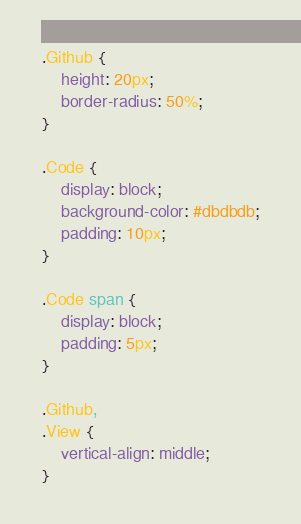<code> <loc_0><loc_0><loc_500><loc_500><_CSS_>.Github {
	height: 20px;
	border-radius: 50%;
}

.Code {
	display: block;
	background-color: #dbdbdb;
	padding: 10px;
}

.Code span {
	display: block;
	padding: 5px;
}

.Github,
.View {
	vertical-align: middle;
}
</code> 